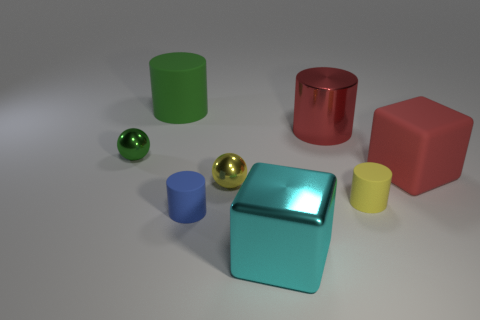Subtract all green rubber cylinders. How many cylinders are left? 3 Subtract all yellow balls. How many balls are left? 1 Add 2 big shiny cylinders. How many objects exist? 10 Subtract 1 blocks. How many blocks are left? 1 Subtract all cubes. How many objects are left? 6 Subtract all purple blocks. How many green spheres are left? 1 Subtract all large yellow shiny objects. Subtract all yellow spheres. How many objects are left? 7 Add 7 blue objects. How many blue objects are left? 8 Add 5 small yellow cylinders. How many small yellow cylinders exist? 6 Subtract 1 cyan blocks. How many objects are left? 7 